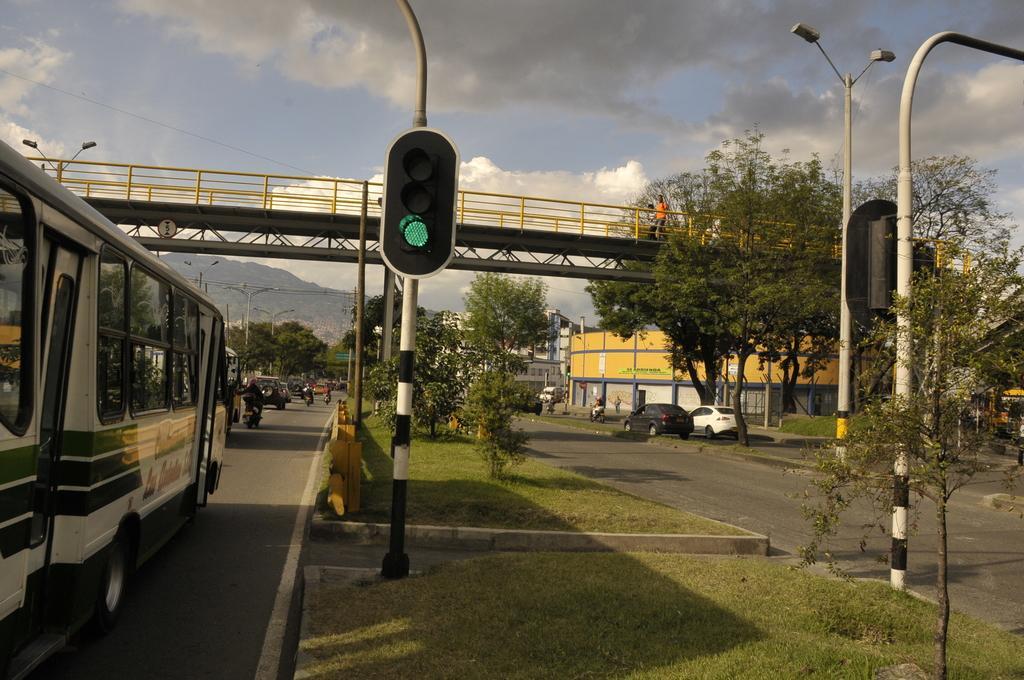Please provide a concise description of this image. In this image in the front there's grass on the ground. In the center there are poles and on the left side there are vehicles moving on the road. In the background there are trees, there is a bridge on the top and there are vehicles on the right side and the sky is cloudy. 